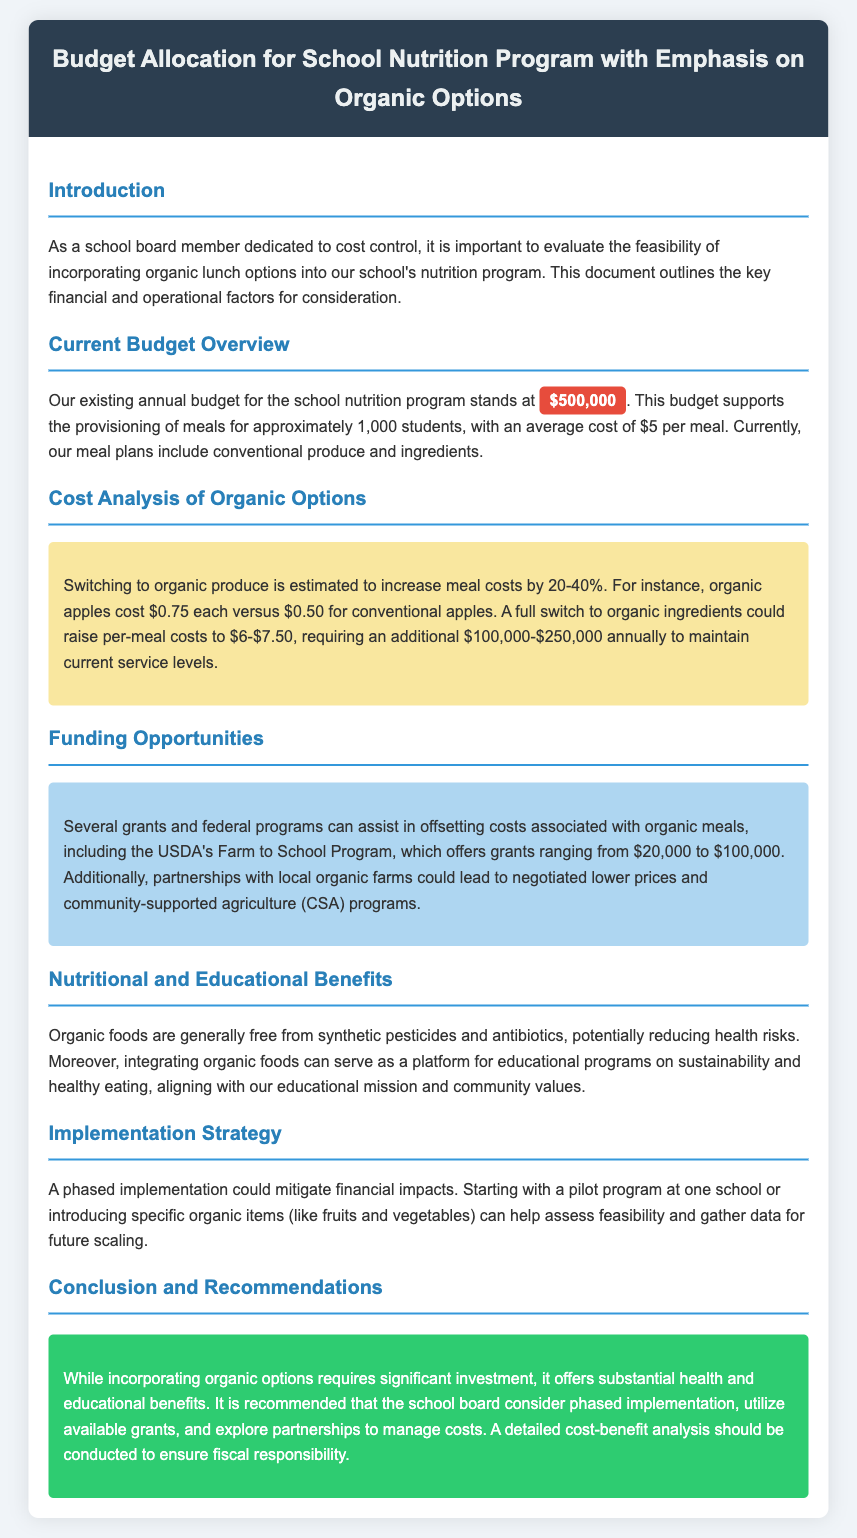What is the current annual budget for the school nutrition program? The current annual budget for the school nutrition program is explicitly stated in the document as $500,000.
Answer: $500,000 By how much could meal costs increase if switching to organic options? The document states that meal costs could increase by 20-40% when switching to organic options.
Answer: 20-40% What is the estimated additional funding required for organic meal options? The document outlines that an additional $100,000-$250,000 would be needed annually to sustain service levels with organic options.
Answer: $100,000-$250,000 What type of grant does the USDA offer for school nutrition? The document mentions that the USDA's Farm to School Program offers grants ranging from $20,000 to $100,000 to help with costs.
Answer: $20,000 to $100,000 What is a suggested implementation strategy for adding organic meals? The document recommends a phased implementation approach, starting with a pilot program or specific organic items.
Answer: Phased implementation What are some health-related benefits of organic foods mentioned in the document? The document states that organic foods are generally free from synthetic pesticides and antibiotics, reducing health risks.
Answer: Reducing health risks How many students does the current budget support? The document states that the current budget supports approximately 1,000 students in the nutrition program.
Answer: 1,000 students What should be conducted to ensure fiscal responsibility regarding organic options? The document suggests that a detailed cost-benefit analysis should be conducted to ensure fiscal responsibility.
Answer: Cost-benefit analysis 